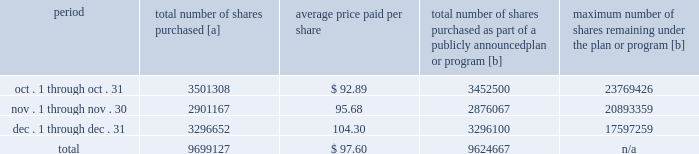Five-year performance comparison 2013 the following graph provides an indicator of cumulative total shareholder returns for the corporation as compared to the peer group index ( described above ) , the dj trans , and the s&p 500 .
The graph assumes that $ 100 was invested in the common stock of union pacific corporation and each index on december 31 , 2011 and that all dividends were reinvested .
The information below is historical in nature and is not necessarily indicative of future performance .
Purchases of equity securities 2013 during 2016 , we repurchased 35686529 shares of our common stock at an average price of $ 88.36 .
The table presents common stock repurchases during each month for the fourth quarter of 2016 : period total number of shares purchased [a] average price paid per share total number of shares purchased as part of a publicly announced plan or program [b] maximum number of shares remaining under the plan or program [b] .
[a] total number of shares purchased during the quarter includes approximately 74460 shares delivered or attested to upc by employees to pay stock option exercise prices , satisfy excess tax withholding obligations for stock option exercises or vesting of retention units , and pay withholding obligations for vesting of retention shares .
[b] effective january 1 , 2014 , our board of directors authorized the repurchase of up to 120 million shares of our common stock by december 31 , 2017 .
These repurchases may be made on the open market or through other transactions .
Our management has sole discretion with respect to determining the timing and amount of these transactions .
On november 17 , 2016 , our board of directors approved the early renewal of the share repurchase program , authorizing the repurchase of up to 120 million shares of our common stock by december 31 , 2020 .
The new authorization was effective january 1 , 2017 , and replaces the previous authorization , which expired on december 31 , 2016. .
What percentage of the total number of shares purchased were purchased in december? 
Computations: (3296652 / 9699127)
Answer: 0.33989. Five-year performance comparison 2013 the following graph provides an indicator of cumulative total shareholder returns for the corporation as compared to the peer group index ( described above ) , the dj trans , and the s&p 500 .
The graph assumes that $ 100 was invested in the common stock of union pacific corporation and each index on december 31 , 2011 and that all dividends were reinvested .
The information below is historical in nature and is not necessarily indicative of future performance .
Purchases of equity securities 2013 during 2016 , we repurchased 35686529 shares of our common stock at an average price of $ 88.36 .
The table presents common stock repurchases during each month for the fourth quarter of 2016 : period total number of shares purchased [a] average price paid per share total number of shares purchased as part of a publicly announced plan or program [b] maximum number of shares remaining under the plan or program [b] .
[a] total number of shares purchased during the quarter includes approximately 74460 shares delivered or attested to upc by employees to pay stock option exercise prices , satisfy excess tax withholding obligations for stock option exercises or vesting of retention units , and pay withholding obligations for vesting of retention shares .
[b] effective january 1 , 2014 , our board of directors authorized the repurchase of up to 120 million shares of our common stock by december 31 , 2017 .
These repurchases may be made on the open market or through other transactions .
Our management has sole discretion with respect to determining the timing and amount of these transactions .
On november 17 , 2016 , our board of directors approved the early renewal of the share repurchase program , authorizing the repurchase of up to 120 million shares of our common stock by december 31 , 2020 .
The new authorization was effective january 1 , 2017 , and replaces the previous authorization , which expired on december 31 , 2016. .
What percentage of the total number of shares purchased were purchased in november? 
Computations: (2901167 / 9699127)
Answer: 0.29912. 